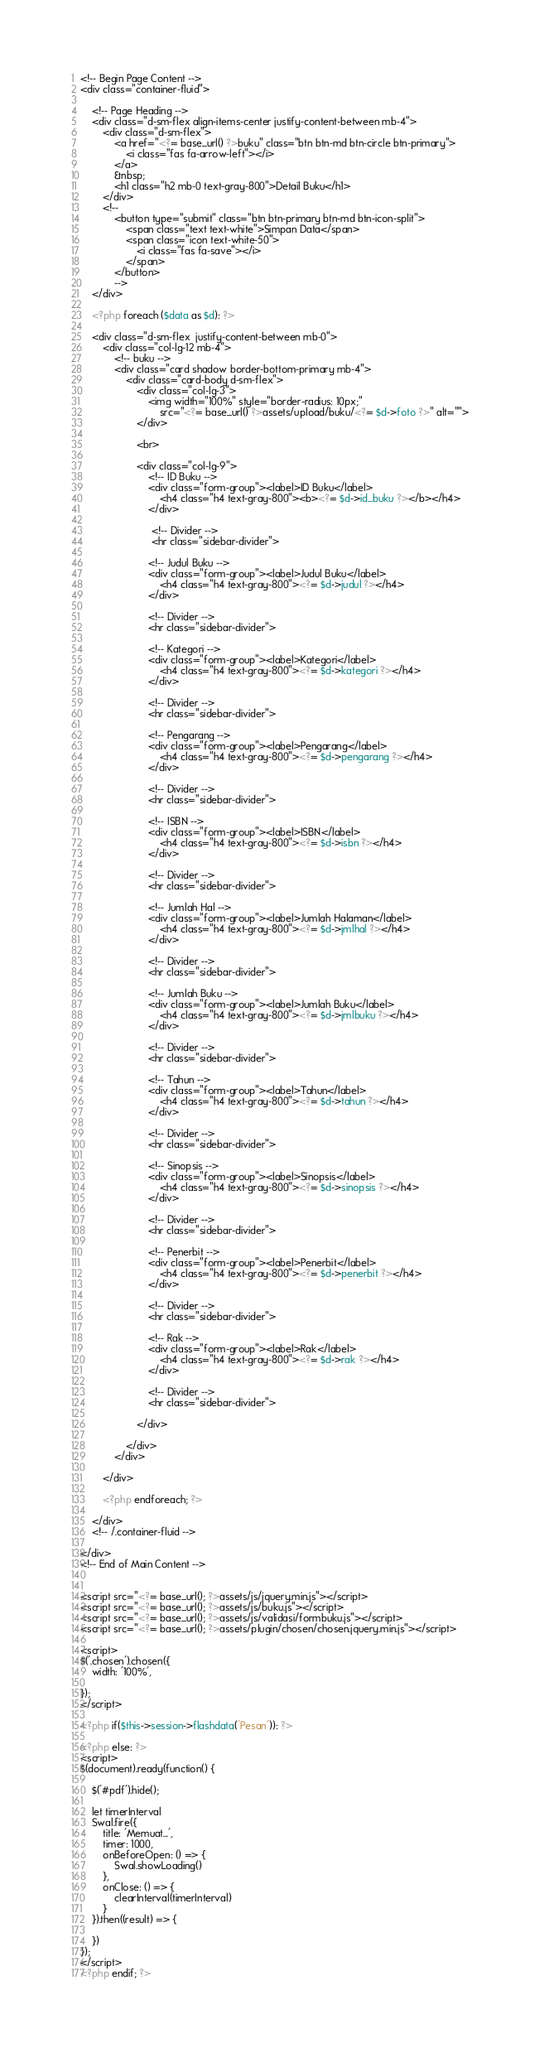Convert code to text. <code><loc_0><loc_0><loc_500><loc_500><_PHP_><!-- Begin Page Content -->
<div class="container-fluid">

    <!-- Page Heading -->
    <div class="d-sm-flex align-items-center justify-content-between mb-4">
        <div class="d-sm-flex">
            <a href="<?= base_url() ?>buku" class="btn btn-md btn-circle btn-primary">
                <i class="fas fa-arrow-left"></i>
            </a>
            &nbsp;
            <h1 class="h2 mb-0 text-gray-800">Detail Buku</h1>
        </div>
        <!-- 
            <button type="submit" class="btn btn-primary btn-md btn-icon-split">
                <span class="text text-white">Simpan Data</span>
                <span class="icon text-white-50">
                    <i class="fas fa-save"></i>
                </span>
            </button>
            -->
    </div>

    <?php foreach ($data as $d): ?>

    <div class="d-sm-flex  justify-content-between mb-0">
        <div class="col-lg-12 mb-4">
            <!-- buku -->
            <div class="card shadow border-bottom-primary mb-4">
                <div class="card-body d-sm-flex">
                    <div class="col-lg-3">
                        <img width="100%" style="border-radius: 10px;"
                            src="<?= base_url() ?>assets/upload/buku/<?= $d->foto ?>" alt="">
                    </div>

                    <br>

                    <div class="col-lg-9">
                        <!-- ID Buku -->
                        <div class="form-group"><label>ID Buku</label>
                            <h4 class="h4 text-gray-800"><b><?= $d->id_buku ?></b></h4>
                        </div>

                         <!-- Divider -->
                         <hr class="sidebar-divider">

                        <!-- Judul Buku -->
                        <div class="form-group"><label>Judul Buku</label>
                            <h4 class="h4 text-gray-800"><?= $d->judul ?></h4>
                        </div>

                        <!-- Divider -->
                        <hr class="sidebar-divider">

                        <!-- Kategori -->
                        <div class="form-group"><label>Kategori</label>
                            <h4 class="h4 text-gray-800"><?= $d->kategori ?></h4>
                        </div>

                        <!-- Divider -->
                        <hr class="sidebar-divider">

                        <!-- Pengarang -->
                        <div class="form-group"><label>Pengarang</label>
                            <h4 class="h4 text-gray-800"><?= $d->pengarang ?></h4>
                        </div>

                        <!-- Divider -->
                        <hr class="sidebar-divider">

                        <!-- ISBN -->
                        <div class="form-group"><label>ISBN</label>
                            <h4 class="h4 text-gray-800"><?= $d->isbn ?></h4>
                        </div>

                        <!-- Divider -->
                        <hr class="sidebar-divider">

                        <!-- Jumlah Hal -->
                        <div class="form-group"><label>Jumlah Halaman</label>
                            <h4 class="h4 text-gray-800"><?= $d->jmlhal ?></h4>
                        </div>

                        <!-- Divider -->
                        <hr class="sidebar-divider">

                        <!-- Jumlah Buku -->
                        <div class="form-group"><label>Jumlah Buku</label>
                            <h4 class="h4 text-gray-800"><?= $d->jmlbuku ?></h4>
                        </div>

                        <!-- Divider -->
                        <hr class="sidebar-divider">

                        <!-- Tahun -->
                        <div class="form-group"><label>Tahun</label>
                            <h4 class="h4 text-gray-800"><?= $d->tahun ?></h4>
                        </div>

                        <!-- Divider -->
                        <hr class="sidebar-divider">

                        <!-- Sinopsis -->
                        <div class="form-group"><label>Sinopsis</label>
                            <h4 class="h4 text-gray-800"><?= $d->sinopsis ?></h4>
                        </div>
                        
                        <!-- Divider -->
                        <hr class="sidebar-divider">

                        <!-- Penerbit -->
                        <div class="form-group"><label>Penerbit</label>
                            <h4 class="h4 text-gray-800"><?= $d->penerbit ?></h4>
                        </div>

                        <!-- Divider -->
                        <hr class="sidebar-divider">

                        <!-- Rak -->
                        <div class="form-group"><label>Rak</label>
                            <h4 class="h4 text-gray-800"><?= $d->rak ?></h4>
                        </div>

                        <!-- Divider -->
                        <hr class="sidebar-divider">

                    </div>

                </div>
            </div>

        </div>

        <?php endforeach; ?>

    </div>
    <!-- /.container-fluid -->

</div>
<!-- End of Main Content -->


<script src="<?= base_url(); ?>assets/js/jquery.min.js"></script>
<script src="<?= base_url(); ?>assets/js/buku.js"></script>
<script src="<?= base_url(); ?>assets/js/validasi/formbuku.js"></script>
<script src="<?= base_url(); ?>assets/plugin/chosen/chosen.jquery.min.js"></script>

<script>
$('.chosen').chosen({
    width: '100%',

});
</script>

<?php if($this->session->flashdata('Pesan')): ?>

<?php else: ?>
<script>
$(document).ready(function() {

    $('#pdf').hide();

    let timerInterval
    Swal.fire({
        title: 'Memuat...',
        timer: 1000,
        onBeforeOpen: () => {
            Swal.showLoading()
        },
        onClose: () => {
            clearInterval(timerInterval)
        }
    }).then((result) => {

    })
});
</script>
<?php endif; ?></code> 